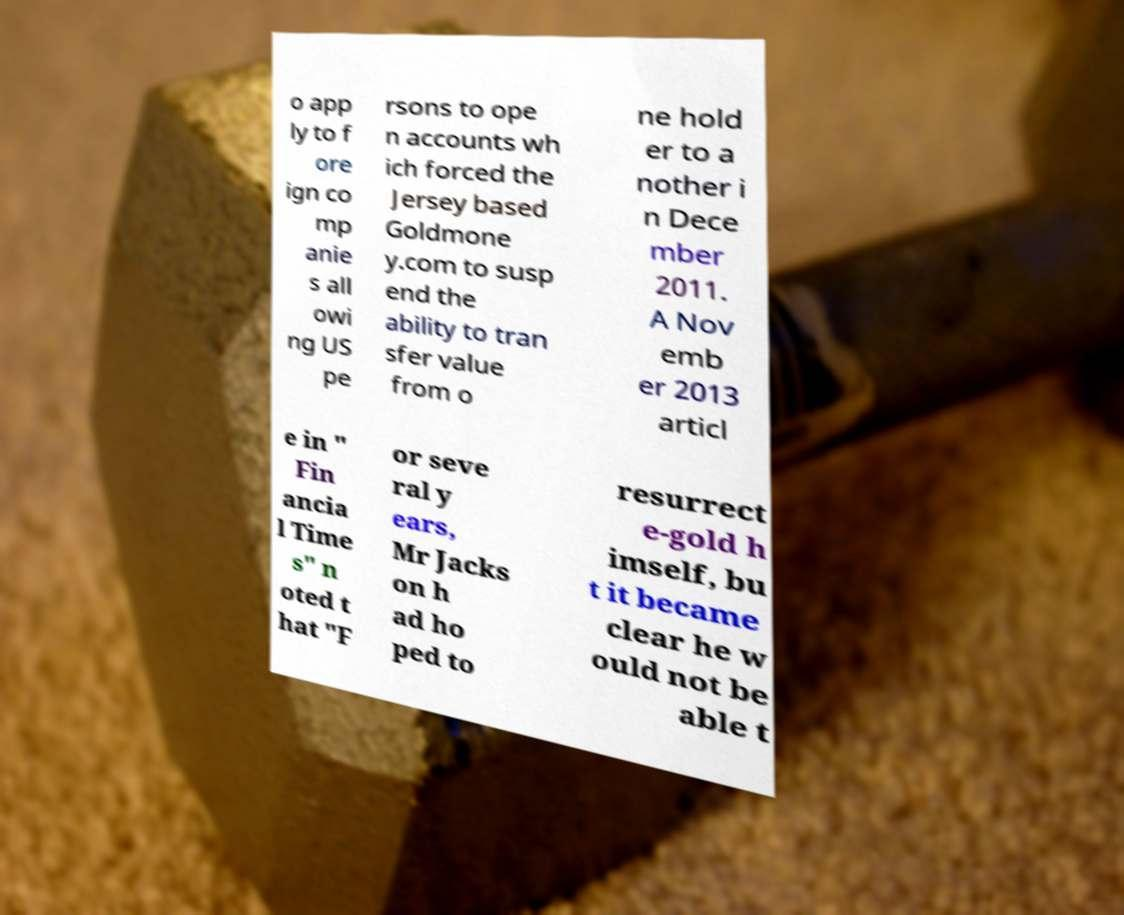There's text embedded in this image that I need extracted. Can you transcribe it verbatim? o app ly to f ore ign co mp anie s all owi ng US pe rsons to ope n accounts wh ich forced the Jersey based Goldmone y.com to susp end the ability to tran sfer value from o ne hold er to a nother i n Dece mber 2011. A Nov emb er 2013 articl e in " Fin ancia l Time s" n oted t hat "F or seve ral y ears, Mr Jacks on h ad ho ped to resurrect e-gold h imself, bu t it became clear he w ould not be able t 